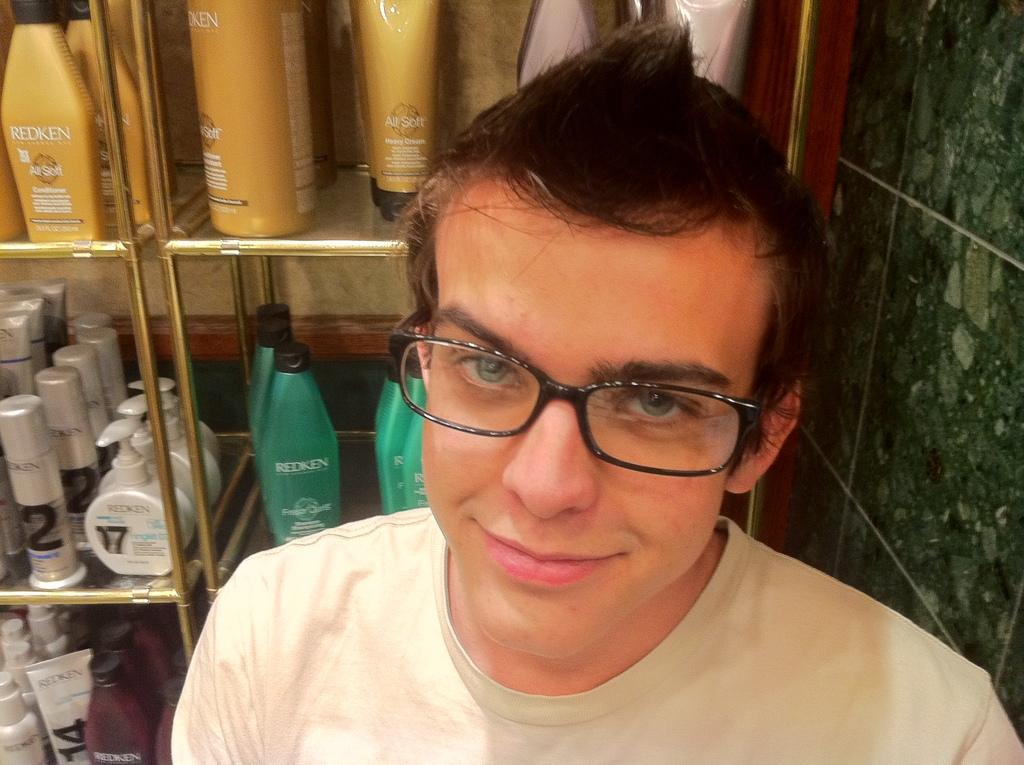<image>
Relay a brief, clear account of the picture shown. A man standing in front of shelves displaying Redken products. 